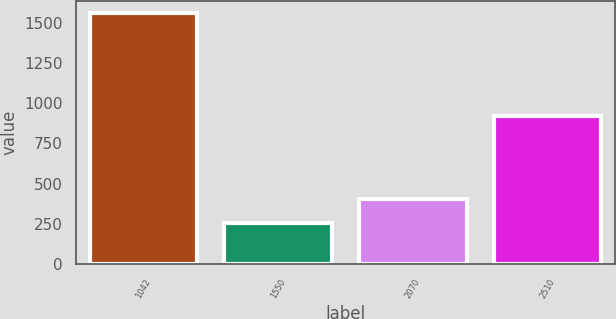<chart> <loc_0><loc_0><loc_500><loc_500><bar_chart><fcel>1042<fcel>1550<fcel>2070<fcel>2510<nl><fcel>1560<fcel>253<fcel>402<fcel>918<nl></chart> 